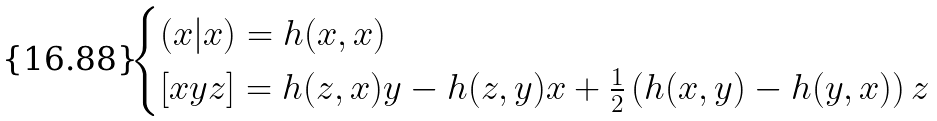Convert formula to latex. <formula><loc_0><loc_0><loc_500><loc_500>\begin{cases} ( x | x ) = h ( x , x ) \\ [ x y z ] = h ( z , x ) y - h ( z , y ) x + \frac { 1 } { 2 } \left ( h ( x , y ) - h ( y , x ) \right ) z \end{cases}</formula> 